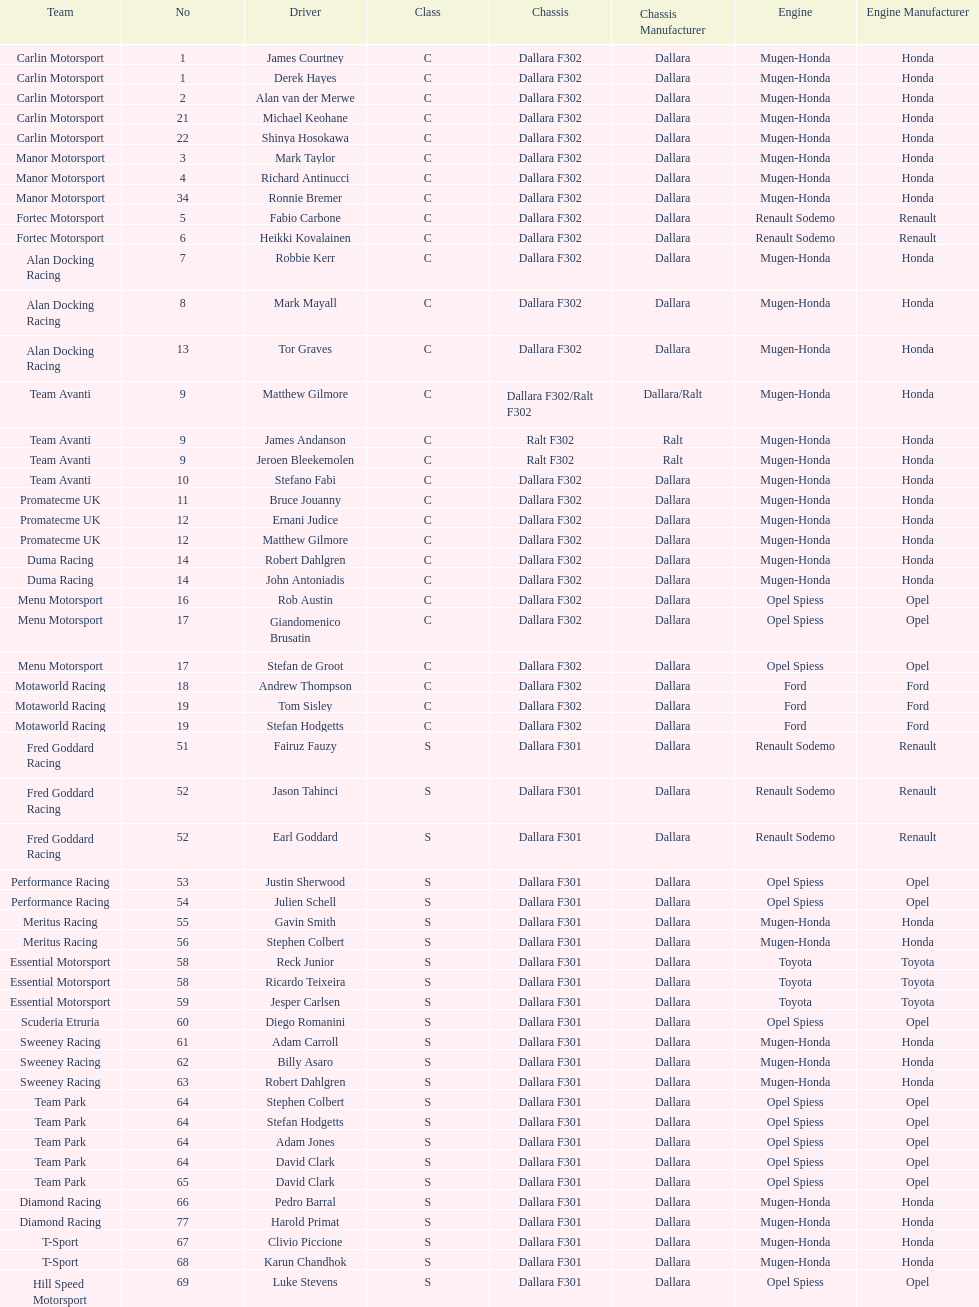Which team had a higher number of drivers, avanti or motaworld racing? Team Avanti. 